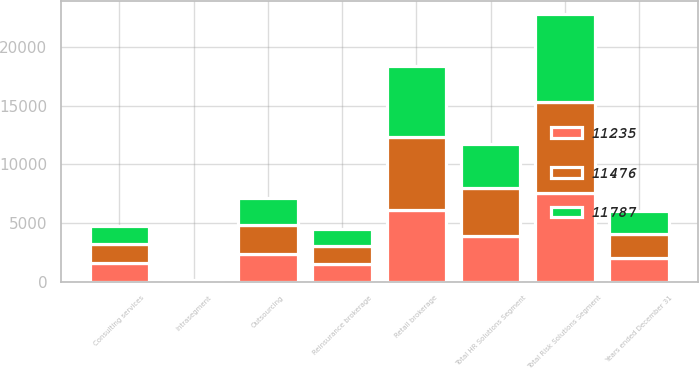Convert chart. <chart><loc_0><loc_0><loc_500><loc_500><stacked_bar_chart><ecel><fcel>Years ended December 31<fcel>Retail brokerage<fcel>Reinsurance brokerage<fcel>Total Risk Solutions Segment<fcel>Consulting services<fcel>Outsourcing<fcel>Intrasegment<fcel>Total HR Solutions Segment<nl><fcel>11476<fcel>2013<fcel>6256<fcel>1505<fcel>7761<fcel>1626<fcel>2469<fcel>38<fcel>4057<nl><fcel>11235<fcel>2012<fcel>6089<fcel>1505<fcel>7594<fcel>1585<fcel>2372<fcel>32<fcel>3925<nl><fcel>11787<fcel>2011<fcel>6022<fcel>1463<fcel>7485<fcel>1546<fcel>2258<fcel>23<fcel>3781<nl></chart> 